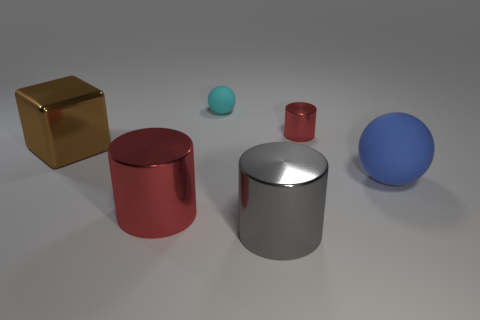What number of large objects are either red metal cylinders or yellow shiny balls?
Keep it short and to the point. 1. Are there fewer tiny yellow shiny spheres than large blocks?
Your answer should be compact. Yes. What color is the other rubber object that is the same shape as the small cyan rubber object?
Offer a very short reply. Blue. Is there anything else that has the same shape as the blue rubber object?
Give a very brief answer. Yes. Is the number of metal things greater than the number of large gray cylinders?
Offer a terse response. Yes. What number of other things are there of the same material as the small sphere
Keep it short and to the point. 1. What shape is the big metal thing that is behind the big blue thing that is to the right of the matte ball that is behind the big matte sphere?
Your answer should be compact. Cube. Is the number of spheres to the left of the gray metallic cylinder less than the number of small red metal cylinders that are on the left side of the big blue thing?
Keep it short and to the point. No. Is there a large rubber object of the same color as the tiny metal thing?
Offer a very short reply. No. Is the large cube made of the same material as the ball that is to the left of the gray shiny object?
Offer a very short reply. No. 